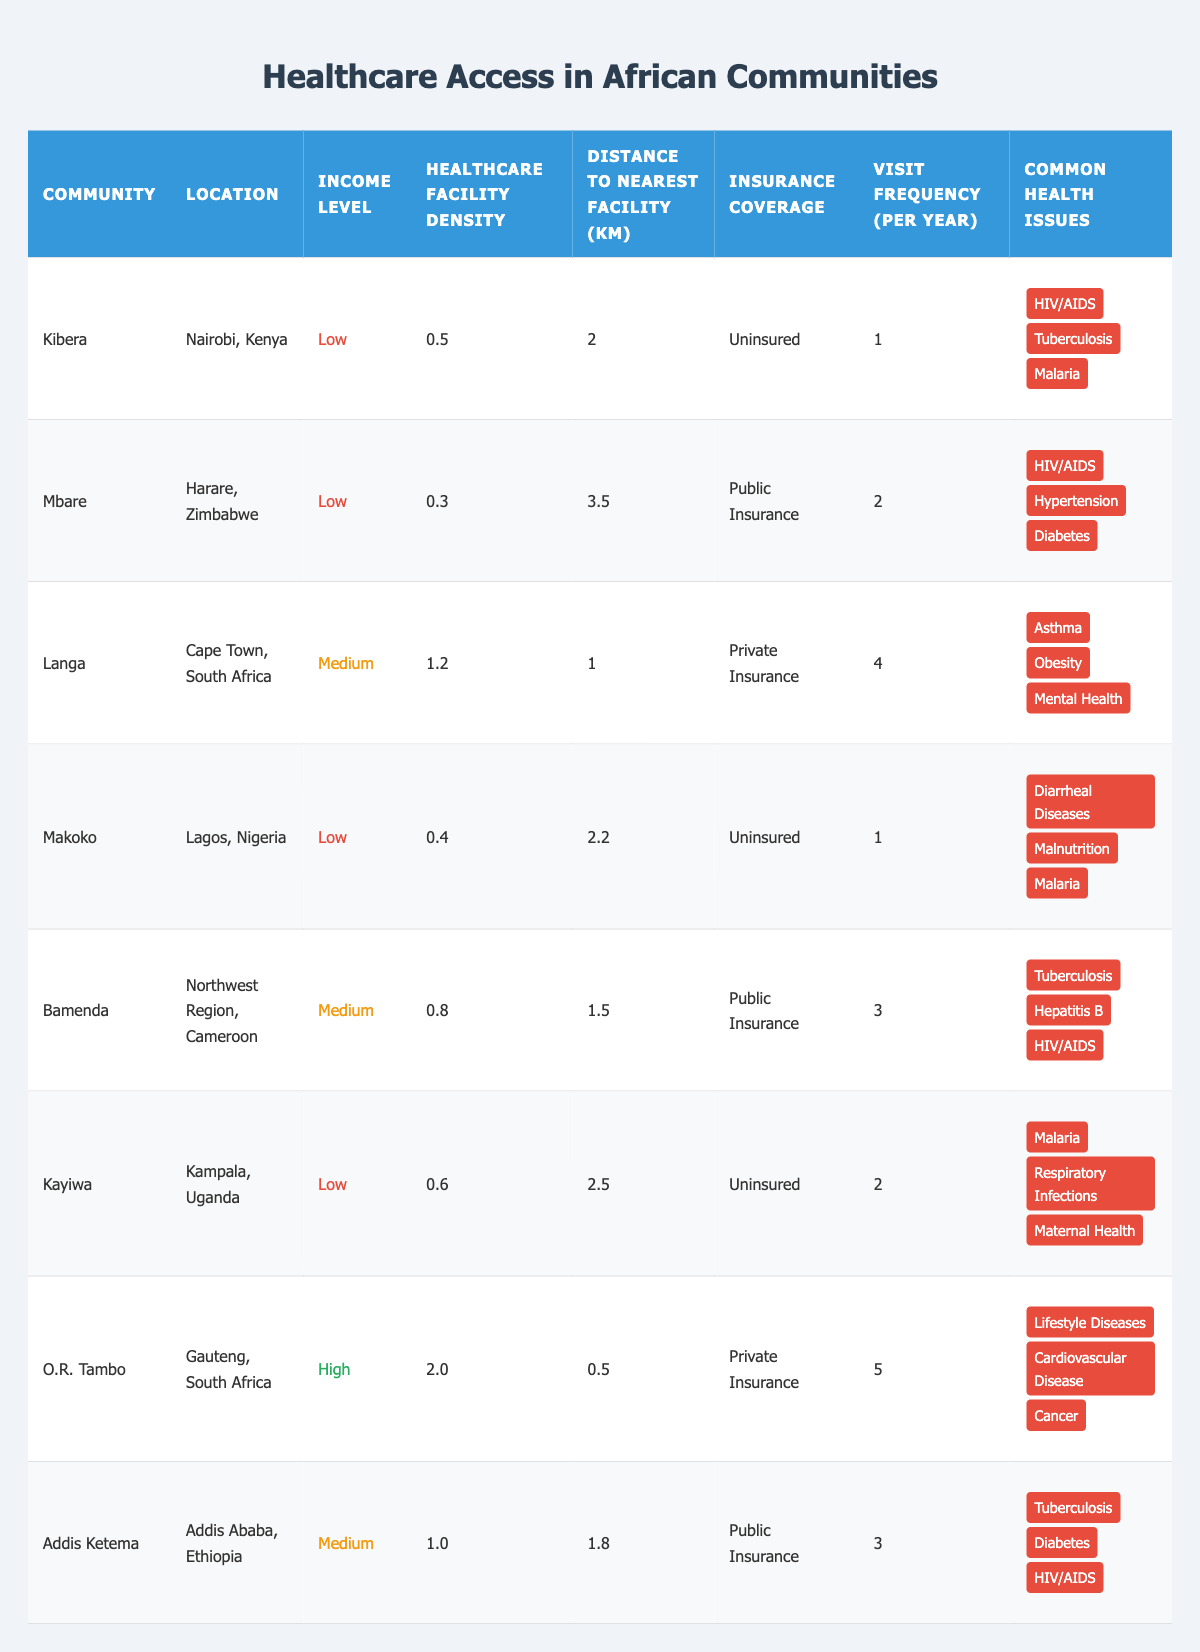What is the healthcare facility density in Kibera? The table shows that Kibera has a healthcare facility density of 0.5.
Answer: 0.5 How many common health issues are reported in the Langa community? The data for Langa lists three common health issues: Asthma, Obesity, and Mental Health.
Answer: 3 Which community has the highest insurance coverage? O.R. Tambo in Gauteng, South Africa has private insurance coverage, which is the highest compared to others that are uninsured or have public insurance.
Answer: O.R. Tambo What is the average distance to the nearest healthcare facility among all low-income communities? The distances to the nearest facility for low-income communities are 2 km (Kibera), 3.5 km (Mbare), 2.2 km (Makoko), and 2.5 km (Kayiwa). The average is (2 + 3.5 + 2.2 + 2.5) / 4 = 2.57 km.
Answer: 2.57 km How often do residents of O.R. Tambo visit healthcare facilities per year? The table indicates that residents of O.R. Tambo visit healthcare facilities 5 times a year.
Answer: 5 Which community has the highest healthcare facility density? O.R. Tambo has the highest healthcare facility density at 2.0.
Answer: O.R. Tambo Is there any community that is uninsured and has a visit frequency of 2 per year? Yes, Kayiwa in Kampala, Uganda is uninsured and has a visit frequency of 2 visits per year.
Answer: Yes What are the common health issues for the community with the highest income level? In O.R. Tambo, the common health issues are Lifestyle Diseases, Cardiovascular Disease, and Cancer.
Answer: Lifestyle Diseases, Cardiovascular Disease, Cancer How many high-income communities are there in the data? There is only one high-income community, which is O.R. Tambo in Gauteng, South Africa.
Answer: 1 What is the difference in visit frequency between the lowest and highest healthcare facility density communities? The lowest density community (Mbare) has a visit frequency of 2, and the highest density community (O.R. Tambo) has 5. The difference is 5 - 2 = 3.
Answer: 3 